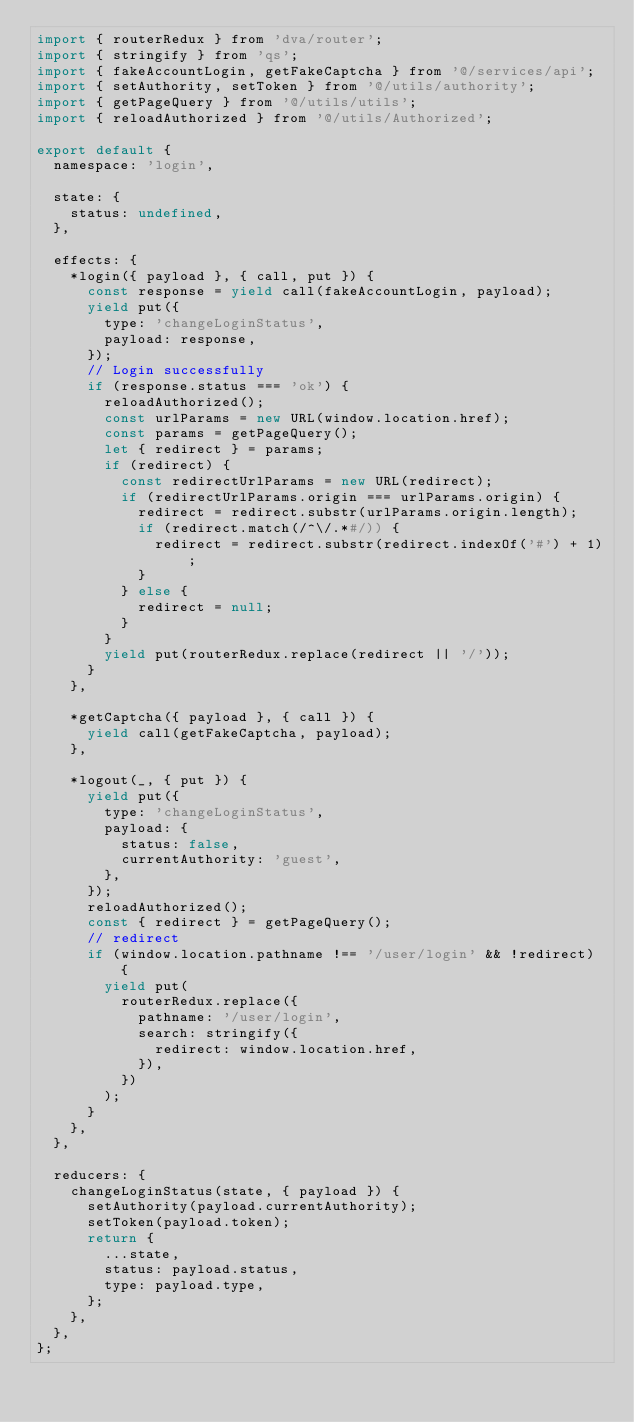<code> <loc_0><loc_0><loc_500><loc_500><_JavaScript_>import { routerRedux } from 'dva/router';
import { stringify } from 'qs';
import { fakeAccountLogin, getFakeCaptcha } from '@/services/api';
import { setAuthority, setToken } from '@/utils/authority';
import { getPageQuery } from '@/utils/utils';
import { reloadAuthorized } from '@/utils/Authorized';

export default {
  namespace: 'login',

  state: {
    status: undefined,
  },

  effects: {
    *login({ payload }, { call, put }) {
      const response = yield call(fakeAccountLogin, payload);
      yield put({
        type: 'changeLoginStatus',
        payload: response,
      });
      // Login successfully
      if (response.status === 'ok') {
        reloadAuthorized();
        const urlParams = new URL(window.location.href);
        const params = getPageQuery();
        let { redirect } = params;
        if (redirect) {
          const redirectUrlParams = new URL(redirect);
          if (redirectUrlParams.origin === urlParams.origin) {
            redirect = redirect.substr(urlParams.origin.length);
            if (redirect.match(/^\/.*#/)) {
              redirect = redirect.substr(redirect.indexOf('#') + 1);
            }
          } else {
            redirect = null;
          }
        }
        yield put(routerRedux.replace(redirect || '/'));
      }
    },

    *getCaptcha({ payload }, { call }) {
      yield call(getFakeCaptcha, payload);
    },

    *logout(_, { put }) {
      yield put({
        type: 'changeLoginStatus',
        payload: {
          status: false,
          currentAuthority: 'guest',
        },
      });
      reloadAuthorized();
      const { redirect } = getPageQuery();
      // redirect
      if (window.location.pathname !== '/user/login' && !redirect) {
        yield put(
          routerRedux.replace({
            pathname: '/user/login',
            search: stringify({
              redirect: window.location.href,
            }),
          })
        );
      }
    },
  },

  reducers: {
    changeLoginStatus(state, { payload }) {
      setAuthority(payload.currentAuthority);
      setToken(payload.token);
      return {
        ...state,
        status: payload.status,
        type: payload.type,
      };
    },
  },
};
</code> 